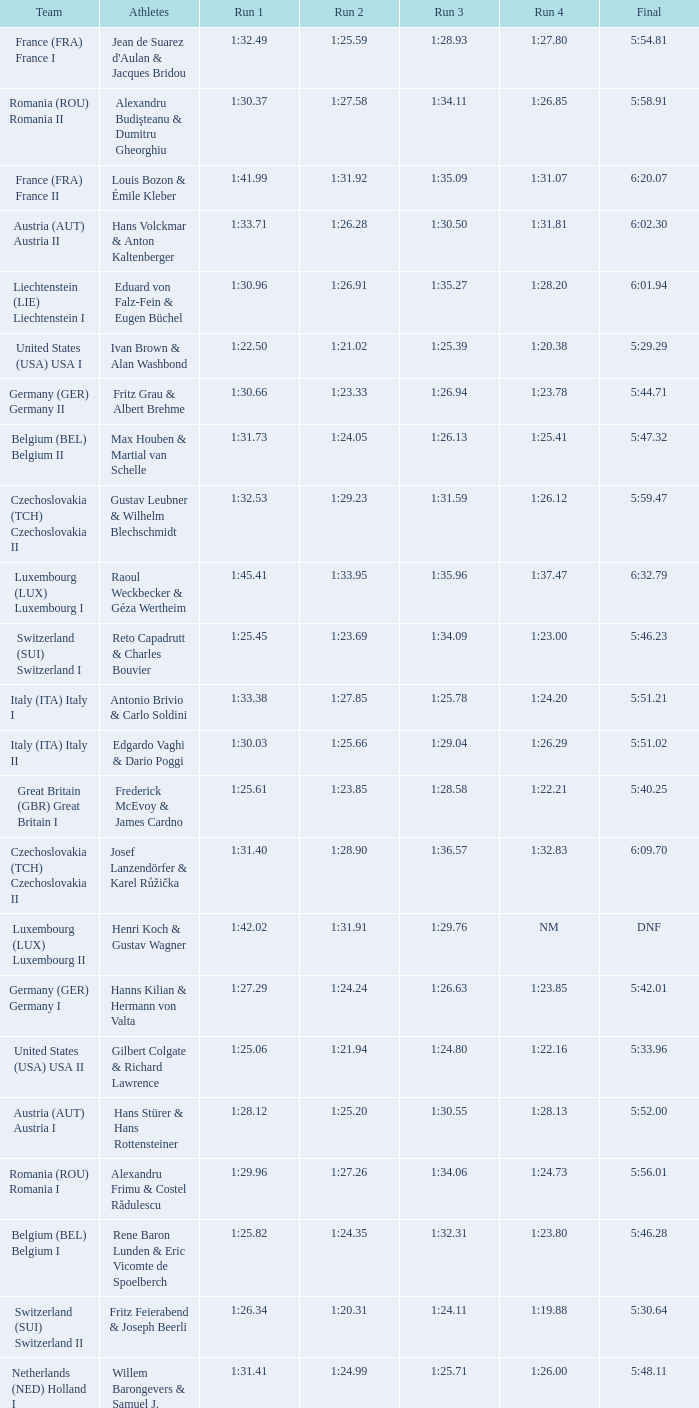Which Final has a Run 2 of 1:27.58? 5:58.91. Can you parse all the data within this table? {'header': ['Team', 'Athletes', 'Run 1', 'Run 2', 'Run 3', 'Run 4', 'Final'], 'rows': [['France (FRA) France I', "Jean de Suarez d'Aulan & Jacques Bridou", '1:32.49', '1:25.59', '1:28.93', '1:27.80', '5:54.81'], ['Romania (ROU) Romania II', 'Alexandru Budişteanu & Dumitru Gheorghiu', '1:30.37', '1:27.58', '1:34.11', '1:26.85', '5:58.91'], ['France (FRA) France II', 'Louis Bozon & Émile Kleber', '1:41.99', '1:31.92', '1:35.09', '1:31.07', '6:20.07'], ['Austria (AUT) Austria II', 'Hans Volckmar & Anton Kaltenberger', '1:33.71', '1:26.28', '1:30.50', '1:31.81', '6:02.30'], ['Liechtenstein (LIE) Liechtenstein I', 'Eduard von Falz-Fein & Eugen Büchel', '1:30.96', '1:26.91', '1:35.27', '1:28.20', '6:01.94'], ['United States (USA) USA I', 'Ivan Brown & Alan Washbond', '1:22.50', '1:21.02', '1:25.39', '1:20.38', '5:29.29'], ['Germany (GER) Germany II', 'Fritz Grau & Albert Brehme', '1:30.66', '1:23.33', '1:26.94', '1:23.78', '5:44.71'], ['Belgium (BEL) Belgium II', 'Max Houben & Martial van Schelle', '1:31.73', '1:24.05', '1:26.13', '1:25.41', '5:47.32'], ['Czechoslovakia (TCH) Czechoslovakia II', 'Gustav Leubner & Wilhelm Blechschmidt', '1:32.53', '1:29.23', '1:31.59', '1:26.12', '5:59.47'], ['Luxembourg (LUX) Luxembourg I', 'Raoul Weckbecker & Géza Wertheim', '1:45.41', '1:33.95', '1:35.96', '1:37.47', '6:32.79'], ['Switzerland (SUI) Switzerland I', 'Reto Capadrutt & Charles Bouvier', '1:25.45', '1:23.69', '1:34.09', '1:23.00', '5:46.23'], ['Italy (ITA) Italy I', 'Antonio Brivio & Carlo Soldini', '1:33.38', '1:27.85', '1:25.78', '1:24.20', '5:51.21'], ['Italy (ITA) Italy II', 'Edgardo Vaghi & Dario Poggi', '1:30.03', '1:25.66', '1:29.04', '1:26.29', '5:51.02'], ['Great Britain (GBR) Great Britain I', 'Frederick McEvoy & James Cardno', '1:25.61', '1:23.85', '1:28.58', '1:22.21', '5:40.25'], ['Czechoslovakia (TCH) Czechoslovakia II', 'Josef Lanzendörfer & Karel Růžička', '1:31.40', '1:28.90', '1:36.57', '1:32.83', '6:09.70'], ['Luxembourg (LUX) Luxembourg II', 'Henri Koch & Gustav Wagner', '1:42.02', '1:31.91', '1:29.76', 'NM', 'DNF'], ['Germany (GER) Germany I', 'Hanns Kilian & Hermann von Valta', '1:27.29', '1:24.24', '1:26.63', '1:23.85', '5:42.01'], ['United States (USA) USA II', 'Gilbert Colgate & Richard Lawrence', '1:25.06', '1:21.94', '1:24.80', '1:22.16', '5:33.96'], ['Austria (AUT) Austria I', 'Hans Stürer & Hans Rottensteiner', '1:28.12', '1:25.20', '1:30.55', '1:28.13', '5:52.00'], ['Romania (ROU) Romania I', 'Alexandru Frimu & Costel Rădulescu', '1:29.96', '1:27.26', '1:34.06', '1:24.73', '5:56.01'], ['Belgium (BEL) Belgium I', 'Rene Baron Lunden & Eric Vicomte de Spoelberch', '1:25.82', '1:24.35', '1:32.31', '1:23.80', '5:46.28'], ['Switzerland (SUI) Switzerland II', 'Fritz Feierabend & Joseph Beerli', '1:26.34', '1:20.31', '1:24.11', '1:19.88', '5:30.64'], ['Netherlands (NED) Holland I', 'Willem Barongevers & Samuel J. Dunlop', '1:31.41', '1:24.99', '1:25.71', '1:26.00', '5:48.11']]} 